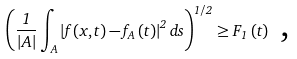Convert formula to latex. <formula><loc_0><loc_0><loc_500><loc_500>\left ( \frac { 1 } { \left | A \right | } \int \nolimits _ { A } \left | f \left ( x , t \right ) - f _ { A } \left ( t \right ) \right | ^ { 2 } d s \right ) ^ { 1 / 2 } \geq F _ { 1 } \left ( t \right ) \text { ,}</formula> 